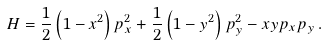Convert formula to latex. <formula><loc_0><loc_0><loc_500><loc_500>H = \frac { 1 } { 2 } \left ( 1 - x ^ { 2 } \right ) p _ { x } ^ { 2 } + \frac { 1 } { 2 } \left ( 1 - y ^ { 2 } \right ) p _ { y } ^ { 2 } - x y p _ { x } p _ { y } \, .</formula> 